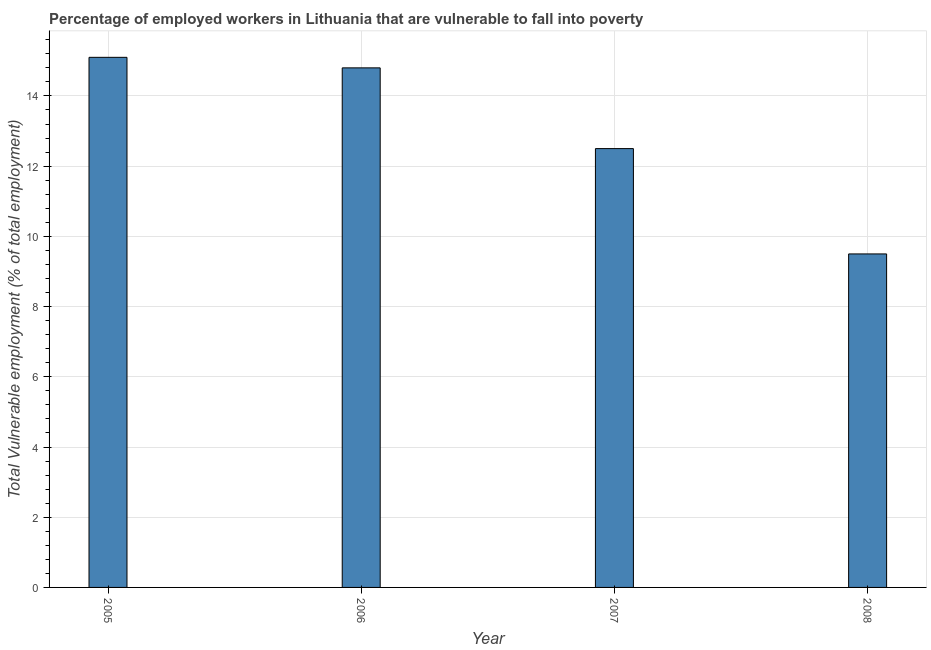Does the graph contain any zero values?
Your answer should be very brief. No. Does the graph contain grids?
Offer a terse response. Yes. What is the title of the graph?
Give a very brief answer. Percentage of employed workers in Lithuania that are vulnerable to fall into poverty. What is the label or title of the X-axis?
Your response must be concise. Year. What is the label or title of the Y-axis?
Provide a succinct answer. Total Vulnerable employment (% of total employment). What is the total vulnerable employment in 2005?
Your answer should be very brief. 15.1. Across all years, what is the maximum total vulnerable employment?
Your answer should be compact. 15.1. Across all years, what is the minimum total vulnerable employment?
Make the answer very short. 9.5. In which year was the total vulnerable employment maximum?
Your answer should be compact. 2005. What is the sum of the total vulnerable employment?
Offer a terse response. 51.9. What is the difference between the total vulnerable employment in 2006 and 2008?
Offer a very short reply. 5.3. What is the average total vulnerable employment per year?
Make the answer very short. 12.97. What is the median total vulnerable employment?
Keep it short and to the point. 13.65. Do a majority of the years between 2008 and 2006 (inclusive) have total vulnerable employment greater than 6 %?
Give a very brief answer. Yes. What is the ratio of the total vulnerable employment in 2006 to that in 2008?
Keep it short and to the point. 1.56. Is the difference between the total vulnerable employment in 2005 and 2006 greater than the difference between any two years?
Give a very brief answer. No. What is the difference between the highest and the second highest total vulnerable employment?
Make the answer very short. 0.3. Is the sum of the total vulnerable employment in 2005 and 2008 greater than the maximum total vulnerable employment across all years?
Provide a short and direct response. Yes. What is the difference between two consecutive major ticks on the Y-axis?
Give a very brief answer. 2. Are the values on the major ticks of Y-axis written in scientific E-notation?
Offer a terse response. No. What is the Total Vulnerable employment (% of total employment) of 2005?
Make the answer very short. 15.1. What is the Total Vulnerable employment (% of total employment) of 2006?
Provide a succinct answer. 14.8. What is the Total Vulnerable employment (% of total employment) in 2008?
Offer a terse response. 9.5. What is the difference between the Total Vulnerable employment (% of total employment) in 2005 and 2006?
Offer a very short reply. 0.3. What is the difference between the Total Vulnerable employment (% of total employment) in 2005 and 2007?
Make the answer very short. 2.6. What is the difference between the Total Vulnerable employment (% of total employment) in 2006 and 2008?
Give a very brief answer. 5.3. What is the ratio of the Total Vulnerable employment (% of total employment) in 2005 to that in 2007?
Offer a very short reply. 1.21. What is the ratio of the Total Vulnerable employment (% of total employment) in 2005 to that in 2008?
Provide a short and direct response. 1.59. What is the ratio of the Total Vulnerable employment (% of total employment) in 2006 to that in 2007?
Your answer should be compact. 1.18. What is the ratio of the Total Vulnerable employment (% of total employment) in 2006 to that in 2008?
Provide a succinct answer. 1.56. What is the ratio of the Total Vulnerable employment (% of total employment) in 2007 to that in 2008?
Offer a very short reply. 1.32. 